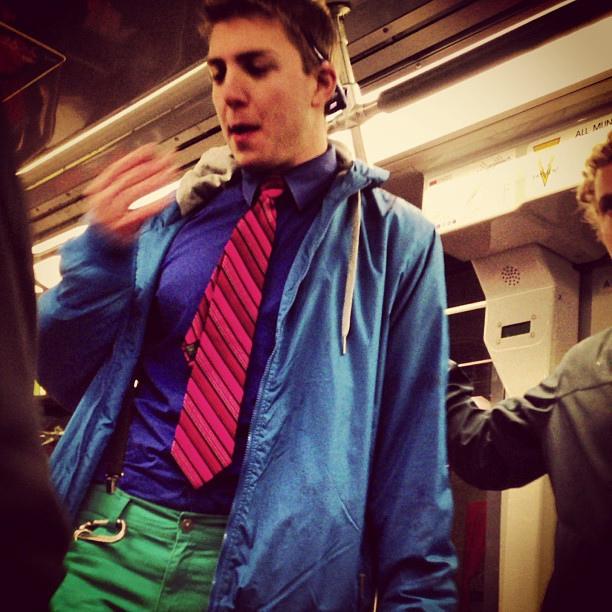Is the man drinking wine?
Give a very brief answer. No. What color tie is this man wearing?
Be succinct. Pink. What does the man in the purple shirt have?
Write a very short answer. Jacket. What color is the tie?
Quick response, please. Red. What is the man doing?
Be succinct. Talking. Are they married?
Answer briefly. No. Is he looking up or down?
Be succinct. Down. Is he at a sporting event?
Concise answer only. No. What is color of the guys pants?
Be succinct. Green. What color are these man's pants?
Keep it brief. Green. What kind of clip is the guy using for his key chain?
Be succinct. Carabiner. Is someone fixing his tie?
Concise answer only. No. Does the man in front have perfect vision?
Short answer required. No. What is the tie  for?
Keep it brief. Interview. What does the man standing up have around his neck?
Concise answer only. Tie. What hand is the man using?
Write a very short answer. Right. 